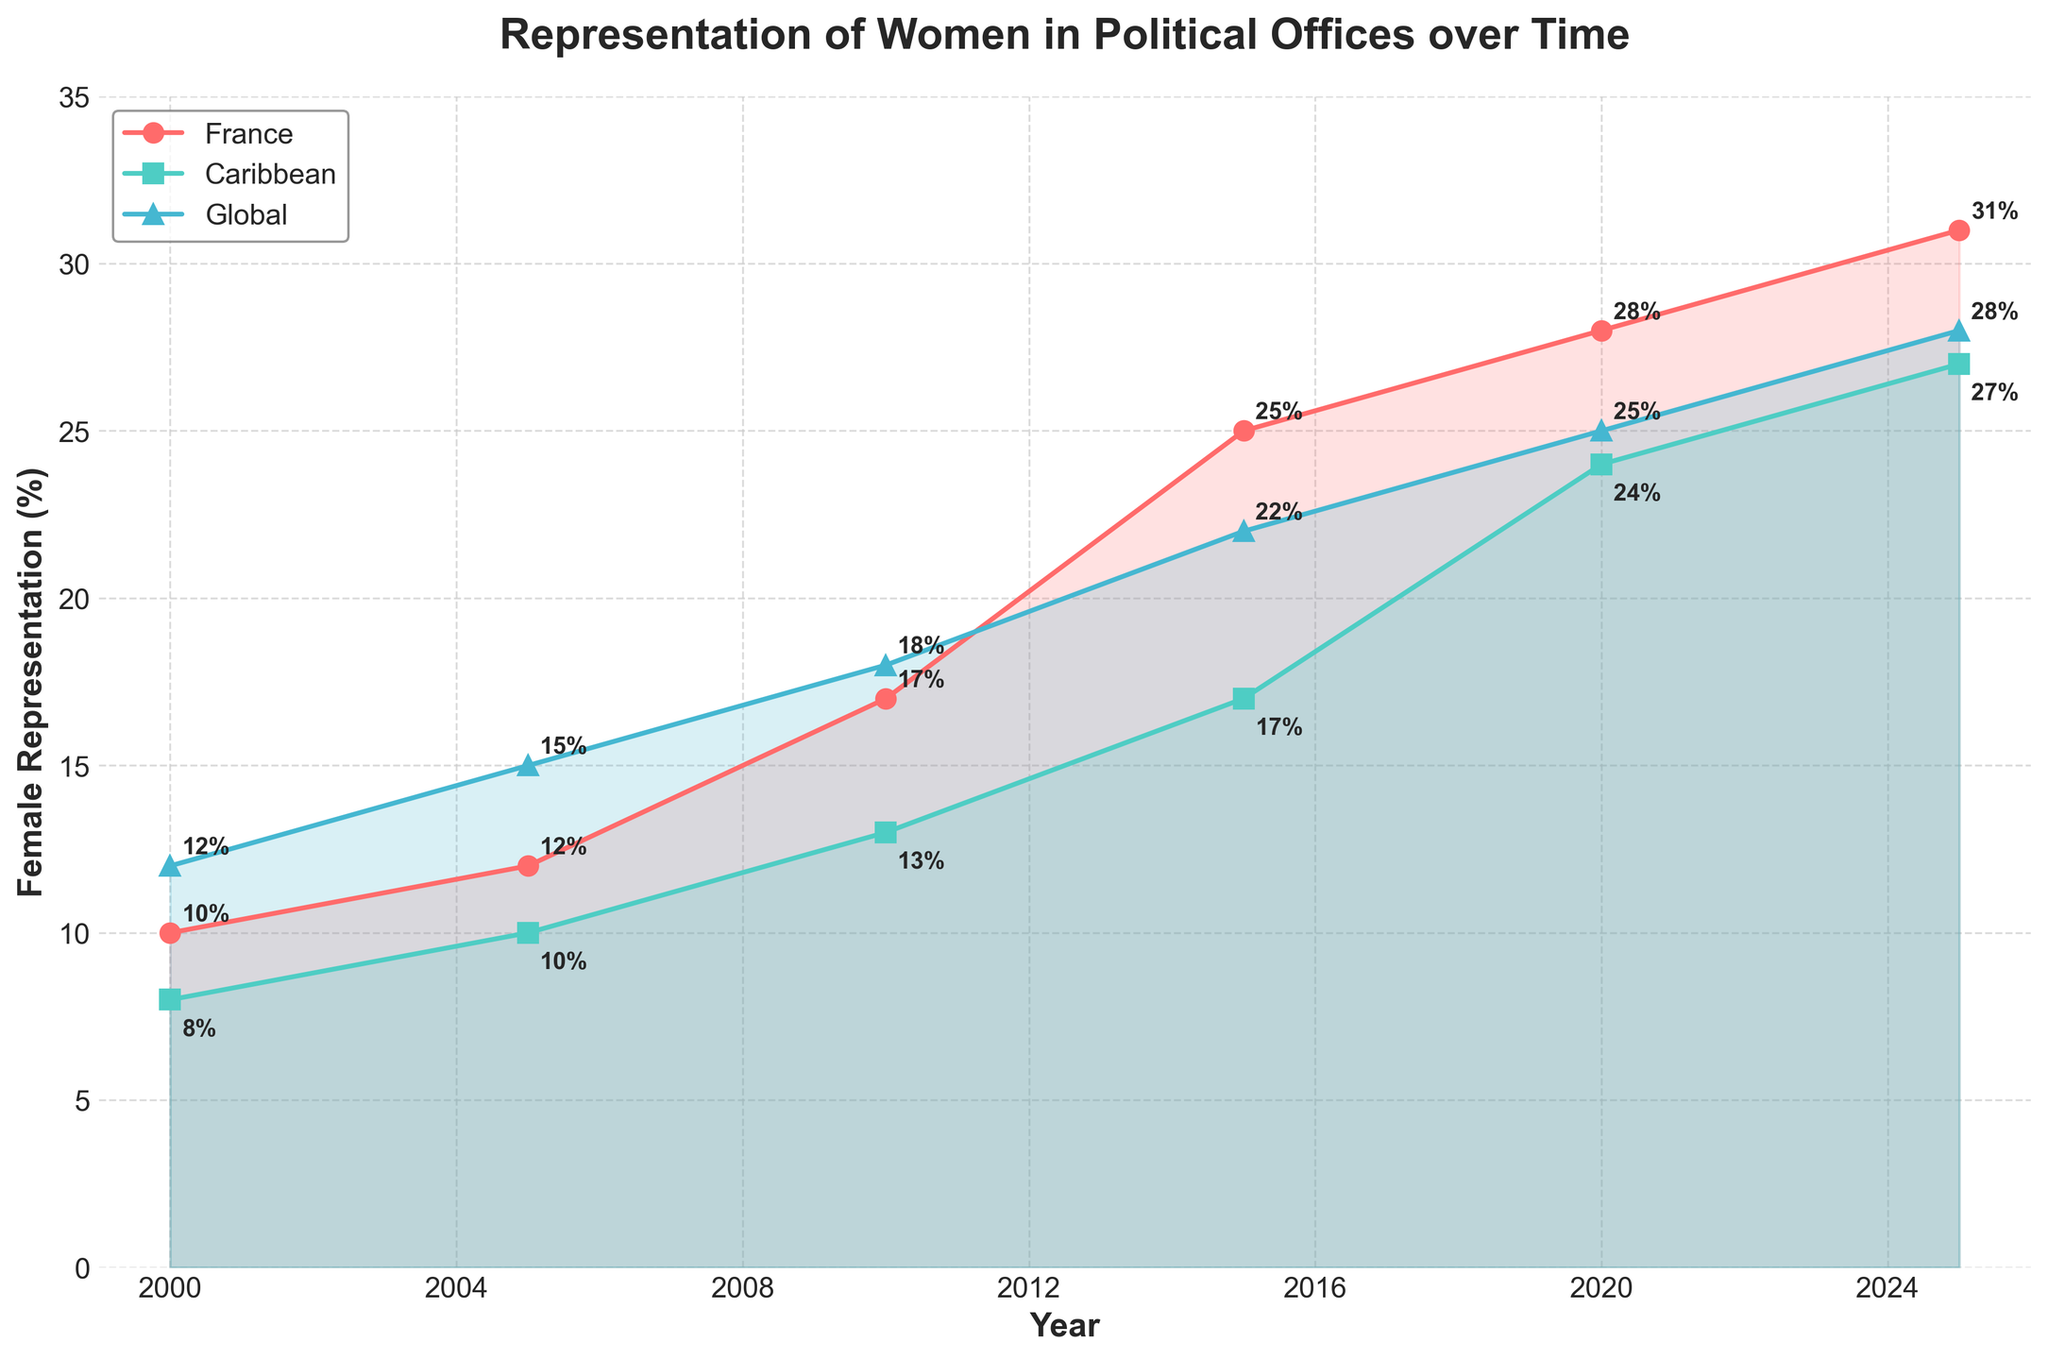What is the title of the graph? The title of the graph is found at the top and clearly states what the graph is about.
Answer: Representation of Women in Political Offices over Time How many countries/regions are represented in the graph? The graph plots data for three distinct lines, each with unique markers and colors.
Answer: Three What was the percentage of female representation in France in 2000? By looking at the point on the France line corresponding to the year 2000, we can find this value annotated.
Answer: 10% How does the female representation in Caribbean political offices in 2025 compare to global representation in the same year? Find the values for the Caribbean and Global representatives in 2025 and compare the two.
Answer: Caribbean: 27%, Global: 28% Which region showed the highest increase in female representation from 2000 to 2020? Calculate the difference in female representation percentages from 2000 to 2020 for each region and compare them.
Answer: France Which year had the highest overall average female representation when considering France, Caribbean, and Global together? For each year, calculate the average of the three values and find the year with the highest average.
Answer: 2025 What is the trend of female representation in France between 2000 and 2025? Analyze the data points for France from 2000 to 2025 to see if there is a rise, steady state, or decline.
Answer: Increasing How does the change in female representation between 2015 and 2020 for the Caribbean compare to the change for France in the same period? Subtract the 2015 value from the 2020 value for both regions and compare these changes.
Answer: Caribbean increased by 7%, France increased by 3% Between 2000 and 2025, in which region is the variance in female representation the greatest? Calculate the variance for the percentage values provided across the years for each region and compare them.
Answer: France 